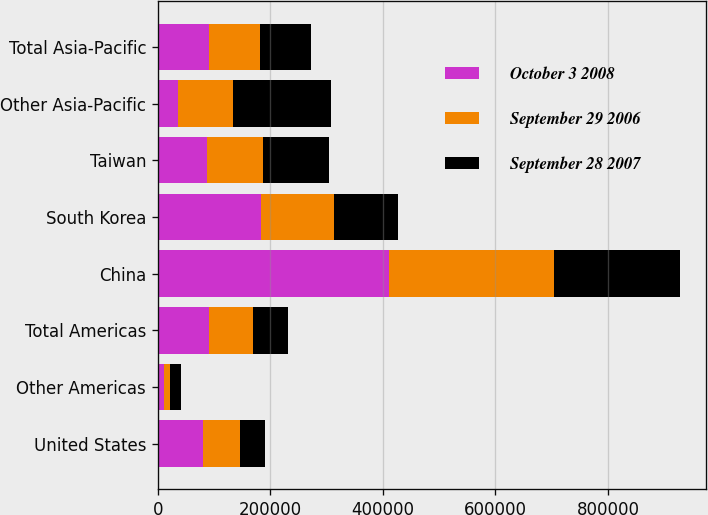Convert chart to OTSL. <chart><loc_0><loc_0><loc_500><loc_500><stacked_bar_chart><ecel><fcel>United States<fcel>Other Americas<fcel>Total Americas<fcel>China<fcel>South Korea<fcel>Taiwan<fcel>Other Asia-Pacific<fcel>Total Asia-Pacific<nl><fcel>October 3 2008<fcel>79952<fcel>10636<fcel>90588<fcel>410645<fcel>184208<fcel>86544<fcel>36005<fcel>90588<nl><fcel>September 29 2006<fcel>66868<fcel>11230<fcel>78098<fcel>293035<fcel>128253<fcel>101107<fcel>98200<fcel>90588<nl><fcel>September 28 2007<fcel>43180<fcel>18925<fcel>62105<fcel>224539<fcel>114926<fcel>116073<fcel>173523<fcel>90588<nl></chart> 